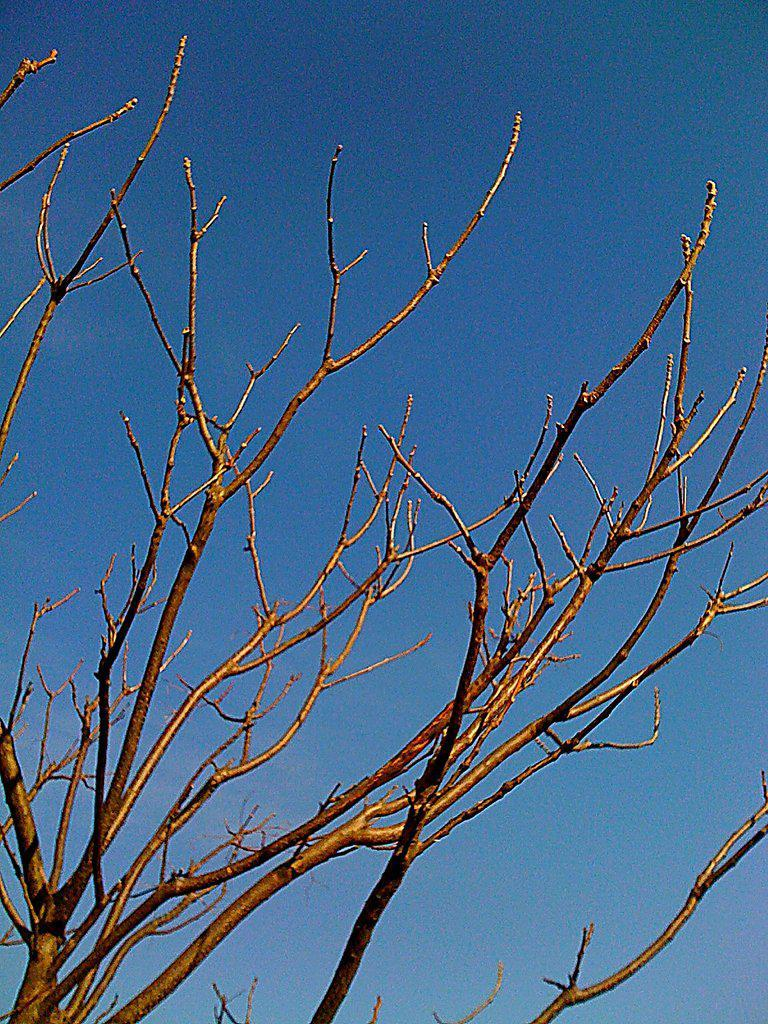What type of vegetation is present in the image? There are branches of a dried tree in the image. What can be seen in the background of the image? The sky is visible in the background of the image. What color is the orange in the image? There is no orange present in the image; it features branches of a dried tree and the sky. 